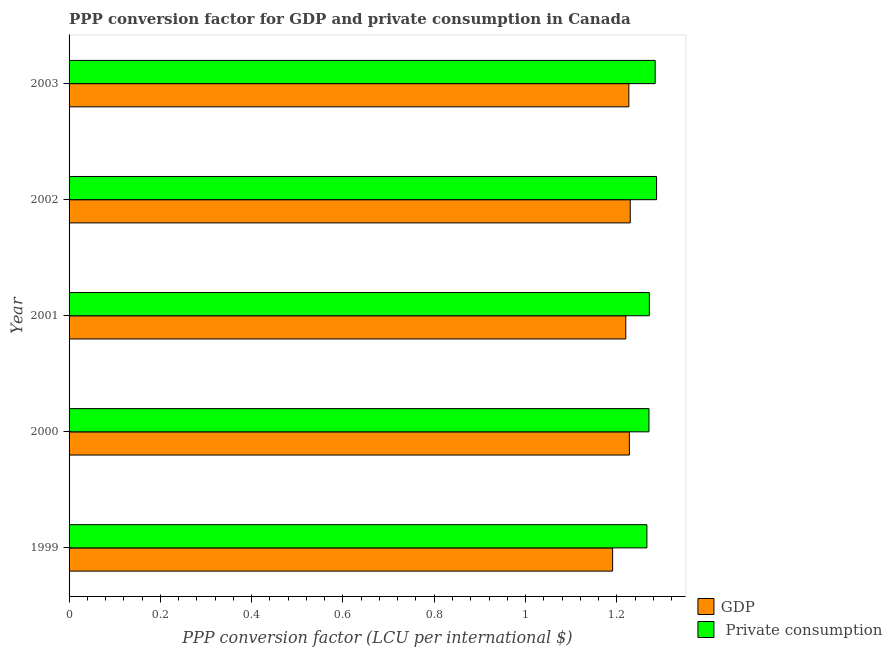Are the number of bars per tick equal to the number of legend labels?
Give a very brief answer. Yes. Are the number of bars on each tick of the Y-axis equal?
Provide a succinct answer. Yes. In how many cases, is the number of bars for a given year not equal to the number of legend labels?
Your answer should be compact. 0. What is the ppp conversion factor for private consumption in 1999?
Your answer should be very brief. 1.27. Across all years, what is the maximum ppp conversion factor for gdp?
Your answer should be very brief. 1.23. Across all years, what is the minimum ppp conversion factor for private consumption?
Ensure brevity in your answer.  1.27. In which year was the ppp conversion factor for private consumption maximum?
Give a very brief answer. 2002. What is the total ppp conversion factor for gdp in the graph?
Your answer should be very brief. 6.09. What is the difference between the ppp conversion factor for private consumption in 2000 and that in 2001?
Give a very brief answer. -0. What is the difference between the ppp conversion factor for private consumption in 2003 and the ppp conversion factor for gdp in 2002?
Offer a terse response. 0.05. What is the average ppp conversion factor for gdp per year?
Make the answer very short. 1.22. In the year 1999, what is the difference between the ppp conversion factor for private consumption and ppp conversion factor for gdp?
Offer a very short reply. 0.07. In how many years, is the ppp conversion factor for private consumption greater than 0.12 LCU?
Keep it short and to the point. 5. What is the ratio of the ppp conversion factor for private consumption in 1999 to that in 2000?
Ensure brevity in your answer.  1. What is the difference between the highest and the second highest ppp conversion factor for gdp?
Provide a succinct answer. 0. In how many years, is the ppp conversion factor for private consumption greater than the average ppp conversion factor for private consumption taken over all years?
Give a very brief answer. 2. Is the sum of the ppp conversion factor for private consumption in 1999 and 2002 greater than the maximum ppp conversion factor for gdp across all years?
Your response must be concise. Yes. What does the 2nd bar from the top in 1999 represents?
Ensure brevity in your answer.  GDP. What does the 2nd bar from the bottom in 2002 represents?
Give a very brief answer.  Private consumption. How many years are there in the graph?
Your response must be concise. 5. How are the legend labels stacked?
Your response must be concise. Vertical. What is the title of the graph?
Provide a succinct answer. PPP conversion factor for GDP and private consumption in Canada. What is the label or title of the X-axis?
Your answer should be very brief. PPP conversion factor (LCU per international $). What is the PPP conversion factor (LCU per international $) of GDP in 1999?
Give a very brief answer. 1.19. What is the PPP conversion factor (LCU per international $) of  Private consumption in 1999?
Make the answer very short. 1.27. What is the PPP conversion factor (LCU per international $) in GDP in 2000?
Your response must be concise. 1.23. What is the PPP conversion factor (LCU per international $) in  Private consumption in 2000?
Offer a very short reply. 1.27. What is the PPP conversion factor (LCU per international $) of GDP in 2001?
Keep it short and to the point. 1.22. What is the PPP conversion factor (LCU per international $) of  Private consumption in 2001?
Offer a very short reply. 1.27. What is the PPP conversion factor (LCU per international $) of GDP in 2002?
Your answer should be very brief. 1.23. What is the PPP conversion factor (LCU per international $) in  Private consumption in 2002?
Give a very brief answer. 1.29. What is the PPP conversion factor (LCU per international $) in GDP in 2003?
Offer a very short reply. 1.23. What is the PPP conversion factor (LCU per international $) in  Private consumption in 2003?
Your answer should be very brief. 1.28. Across all years, what is the maximum PPP conversion factor (LCU per international $) in GDP?
Offer a very short reply. 1.23. Across all years, what is the maximum PPP conversion factor (LCU per international $) of  Private consumption?
Keep it short and to the point. 1.29. Across all years, what is the minimum PPP conversion factor (LCU per international $) of GDP?
Keep it short and to the point. 1.19. Across all years, what is the minimum PPP conversion factor (LCU per international $) of  Private consumption?
Your response must be concise. 1.27. What is the total PPP conversion factor (LCU per international $) in GDP in the graph?
Your answer should be very brief. 6.09. What is the total PPP conversion factor (LCU per international $) in  Private consumption in the graph?
Your answer should be compact. 6.38. What is the difference between the PPP conversion factor (LCU per international $) of GDP in 1999 and that in 2000?
Ensure brevity in your answer.  -0.04. What is the difference between the PPP conversion factor (LCU per international $) of  Private consumption in 1999 and that in 2000?
Your answer should be very brief. -0. What is the difference between the PPP conversion factor (LCU per international $) of GDP in 1999 and that in 2001?
Your answer should be compact. -0.03. What is the difference between the PPP conversion factor (LCU per international $) of  Private consumption in 1999 and that in 2001?
Make the answer very short. -0.01. What is the difference between the PPP conversion factor (LCU per international $) in GDP in 1999 and that in 2002?
Keep it short and to the point. -0.04. What is the difference between the PPP conversion factor (LCU per international $) of  Private consumption in 1999 and that in 2002?
Offer a very short reply. -0.02. What is the difference between the PPP conversion factor (LCU per international $) of GDP in 1999 and that in 2003?
Ensure brevity in your answer.  -0.04. What is the difference between the PPP conversion factor (LCU per international $) of  Private consumption in 1999 and that in 2003?
Make the answer very short. -0.02. What is the difference between the PPP conversion factor (LCU per international $) of GDP in 2000 and that in 2001?
Your response must be concise. 0.01. What is the difference between the PPP conversion factor (LCU per international $) in  Private consumption in 2000 and that in 2001?
Your response must be concise. -0. What is the difference between the PPP conversion factor (LCU per international $) in GDP in 2000 and that in 2002?
Your answer should be compact. -0. What is the difference between the PPP conversion factor (LCU per international $) in  Private consumption in 2000 and that in 2002?
Your answer should be very brief. -0.02. What is the difference between the PPP conversion factor (LCU per international $) in GDP in 2000 and that in 2003?
Your answer should be compact. 0. What is the difference between the PPP conversion factor (LCU per international $) in  Private consumption in 2000 and that in 2003?
Offer a terse response. -0.01. What is the difference between the PPP conversion factor (LCU per international $) of GDP in 2001 and that in 2002?
Provide a short and direct response. -0.01. What is the difference between the PPP conversion factor (LCU per international $) in  Private consumption in 2001 and that in 2002?
Provide a short and direct response. -0.02. What is the difference between the PPP conversion factor (LCU per international $) in GDP in 2001 and that in 2003?
Your answer should be compact. -0.01. What is the difference between the PPP conversion factor (LCU per international $) in  Private consumption in 2001 and that in 2003?
Ensure brevity in your answer.  -0.01. What is the difference between the PPP conversion factor (LCU per international $) of GDP in 2002 and that in 2003?
Ensure brevity in your answer.  0. What is the difference between the PPP conversion factor (LCU per international $) of  Private consumption in 2002 and that in 2003?
Your answer should be compact. 0. What is the difference between the PPP conversion factor (LCU per international $) in GDP in 1999 and the PPP conversion factor (LCU per international $) in  Private consumption in 2000?
Make the answer very short. -0.08. What is the difference between the PPP conversion factor (LCU per international $) of GDP in 1999 and the PPP conversion factor (LCU per international $) of  Private consumption in 2001?
Your answer should be very brief. -0.08. What is the difference between the PPP conversion factor (LCU per international $) in GDP in 1999 and the PPP conversion factor (LCU per international $) in  Private consumption in 2002?
Offer a very short reply. -0.1. What is the difference between the PPP conversion factor (LCU per international $) in GDP in 1999 and the PPP conversion factor (LCU per international $) in  Private consumption in 2003?
Offer a very short reply. -0.09. What is the difference between the PPP conversion factor (LCU per international $) in GDP in 2000 and the PPP conversion factor (LCU per international $) in  Private consumption in 2001?
Give a very brief answer. -0.04. What is the difference between the PPP conversion factor (LCU per international $) in GDP in 2000 and the PPP conversion factor (LCU per international $) in  Private consumption in 2002?
Give a very brief answer. -0.06. What is the difference between the PPP conversion factor (LCU per international $) of GDP in 2000 and the PPP conversion factor (LCU per international $) of  Private consumption in 2003?
Your answer should be compact. -0.06. What is the difference between the PPP conversion factor (LCU per international $) of GDP in 2001 and the PPP conversion factor (LCU per international $) of  Private consumption in 2002?
Offer a terse response. -0.07. What is the difference between the PPP conversion factor (LCU per international $) of GDP in 2001 and the PPP conversion factor (LCU per international $) of  Private consumption in 2003?
Your response must be concise. -0.06. What is the difference between the PPP conversion factor (LCU per international $) in GDP in 2002 and the PPP conversion factor (LCU per international $) in  Private consumption in 2003?
Provide a short and direct response. -0.05. What is the average PPP conversion factor (LCU per international $) in GDP per year?
Offer a very short reply. 1.22. What is the average PPP conversion factor (LCU per international $) in  Private consumption per year?
Give a very brief answer. 1.28. In the year 1999, what is the difference between the PPP conversion factor (LCU per international $) in GDP and PPP conversion factor (LCU per international $) in  Private consumption?
Make the answer very short. -0.07. In the year 2000, what is the difference between the PPP conversion factor (LCU per international $) of GDP and PPP conversion factor (LCU per international $) of  Private consumption?
Offer a terse response. -0.04. In the year 2001, what is the difference between the PPP conversion factor (LCU per international $) in GDP and PPP conversion factor (LCU per international $) in  Private consumption?
Ensure brevity in your answer.  -0.05. In the year 2002, what is the difference between the PPP conversion factor (LCU per international $) of GDP and PPP conversion factor (LCU per international $) of  Private consumption?
Provide a short and direct response. -0.06. In the year 2003, what is the difference between the PPP conversion factor (LCU per international $) in GDP and PPP conversion factor (LCU per international $) in  Private consumption?
Provide a succinct answer. -0.06. What is the ratio of the PPP conversion factor (LCU per international $) of GDP in 1999 to that in 2000?
Make the answer very short. 0.97. What is the ratio of the PPP conversion factor (LCU per international $) in GDP in 1999 to that in 2001?
Ensure brevity in your answer.  0.98. What is the ratio of the PPP conversion factor (LCU per international $) of GDP in 1999 to that in 2002?
Your response must be concise. 0.97. What is the ratio of the PPP conversion factor (LCU per international $) of  Private consumption in 1999 to that in 2002?
Offer a very short reply. 0.98. What is the ratio of the PPP conversion factor (LCU per international $) of  Private consumption in 1999 to that in 2003?
Give a very brief answer. 0.99. What is the ratio of the PPP conversion factor (LCU per international $) in  Private consumption in 2000 to that in 2001?
Give a very brief answer. 1. What is the ratio of the PPP conversion factor (LCU per international $) of GDP in 2000 to that in 2002?
Provide a short and direct response. 1. What is the ratio of the PPP conversion factor (LCU per international $) of  Private consumption in 2000 to that in 2002?
Ensure brevity in your answer.  0.99. What is the ratio of the PPP conversion factor (LCU per international $) in GDP in 2000 to that in 2003?
Your answer should be very brief. 1. What is the ratio of the PPP conversion factor (LCU per international $) of  Private consumption in 2000 to that in 2003?
Give a very brief answer. 0.99. What is the ratio of the PPP conversion factor (LCU per international $) of  Private consumption in 2001 to that in 2002?
Keep it short and to the point. 0.99. What is the ratio of the PPP conversion factor (LCU per international $) of GDP in 2002 to that in 2003?
Give a very brief answer. 1. What is the difference between the highest and the second highest PPP conversion factor (LCU per international $) of GDP?
Provide a succinct answer. 0. What is the difference between the highest and the second highest PPP conversion factor (LCU per international $) in  Private consumption?
Offer a terse response. 0. What is the difference between the highest and the lowest PPP conversion factor (LCU per international $) of GDP?
Your answer should be compact. 0.04. What is the difference between the highest and the lowest PPP conversion factor (LCU per international $) of  Private consumption?
Provide a succinct answer. 0.02. 